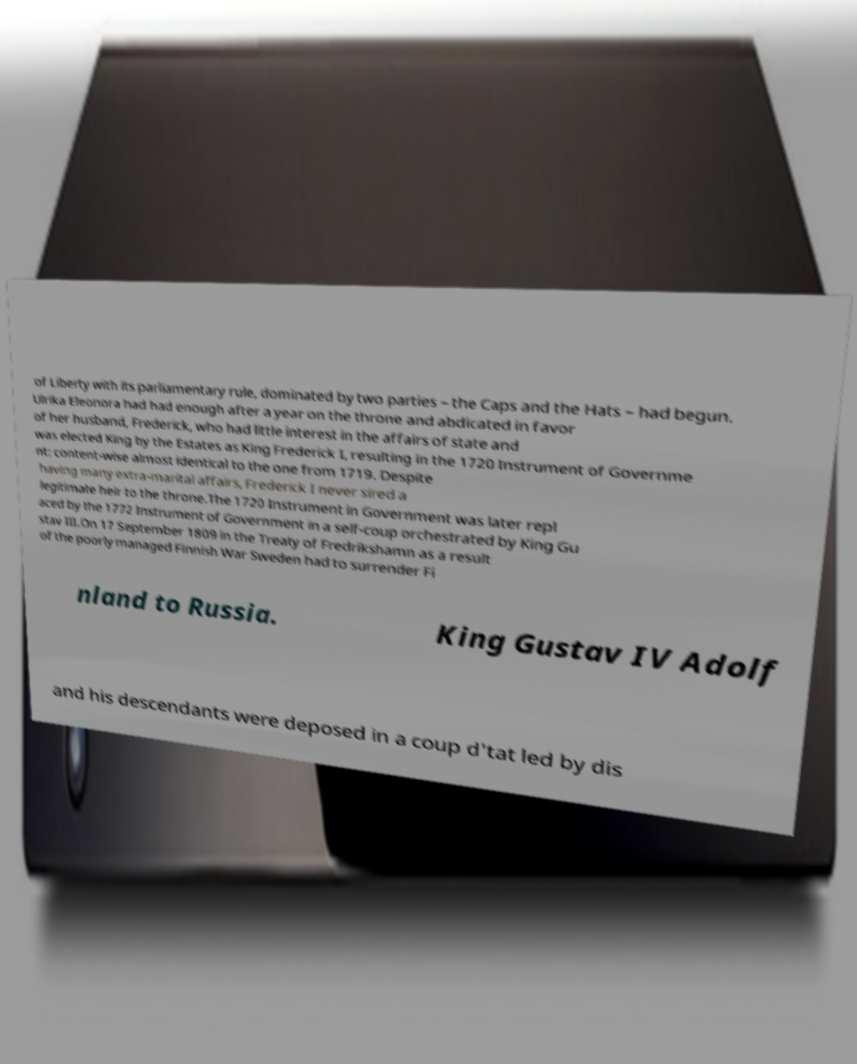For documentation purposes, I need the text within this image transcribed. Could you provide that? of Liberty with its parliamentary rule, dominated by two parties – the Caps and the Hats – had begun. Ulrika Eleonora had had enough after a year on the throne and abdicated in favor of her husband, Frederick, who had little interest in the affairs of state and was elected King by the Estates as King Frederick I, resulting in the 1720 Instrument of Governme nt: content-wise almost identical to the one from 1719. Despite having many extra-marital affairs, Frederick I never sired a legitimate heir to the throne.The 1720 Instrument in Government was later repl aced by the 1772 Instrument of Government in a self-coup orchestrated by King Gu stav III.On 17 September 1809 in the Treaty of Fredrikshamn as a result of the poorly managed Finnish War Sweden had to surrender Fi nland to Russia. King Gustav IV Adolf and his descendants were deposed in a coup d'tat led by dis 